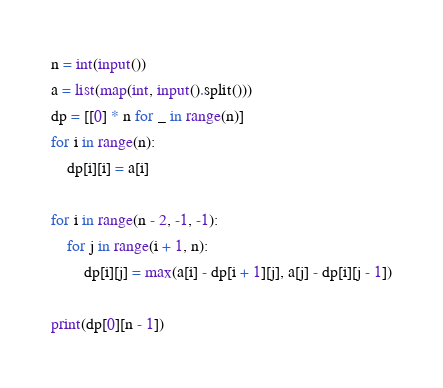Convert code to text. <code><loc_0><loc_0><loc_500><loc_500><_Python_>n = int(input())
a = list(map(int, input().split()))
dp = [[0] * n for _ in range(n)]
for i in range(n):
    dp[i][i] = a[i]

for i in range(n - 2, -1, -1):
    for j in range(i + 1, n):
        dp[i][j] = max(a[i] - dp[i + 1][j], a[j] - dp[i][j - 1])

print(dp[0][n - 1])</code> 